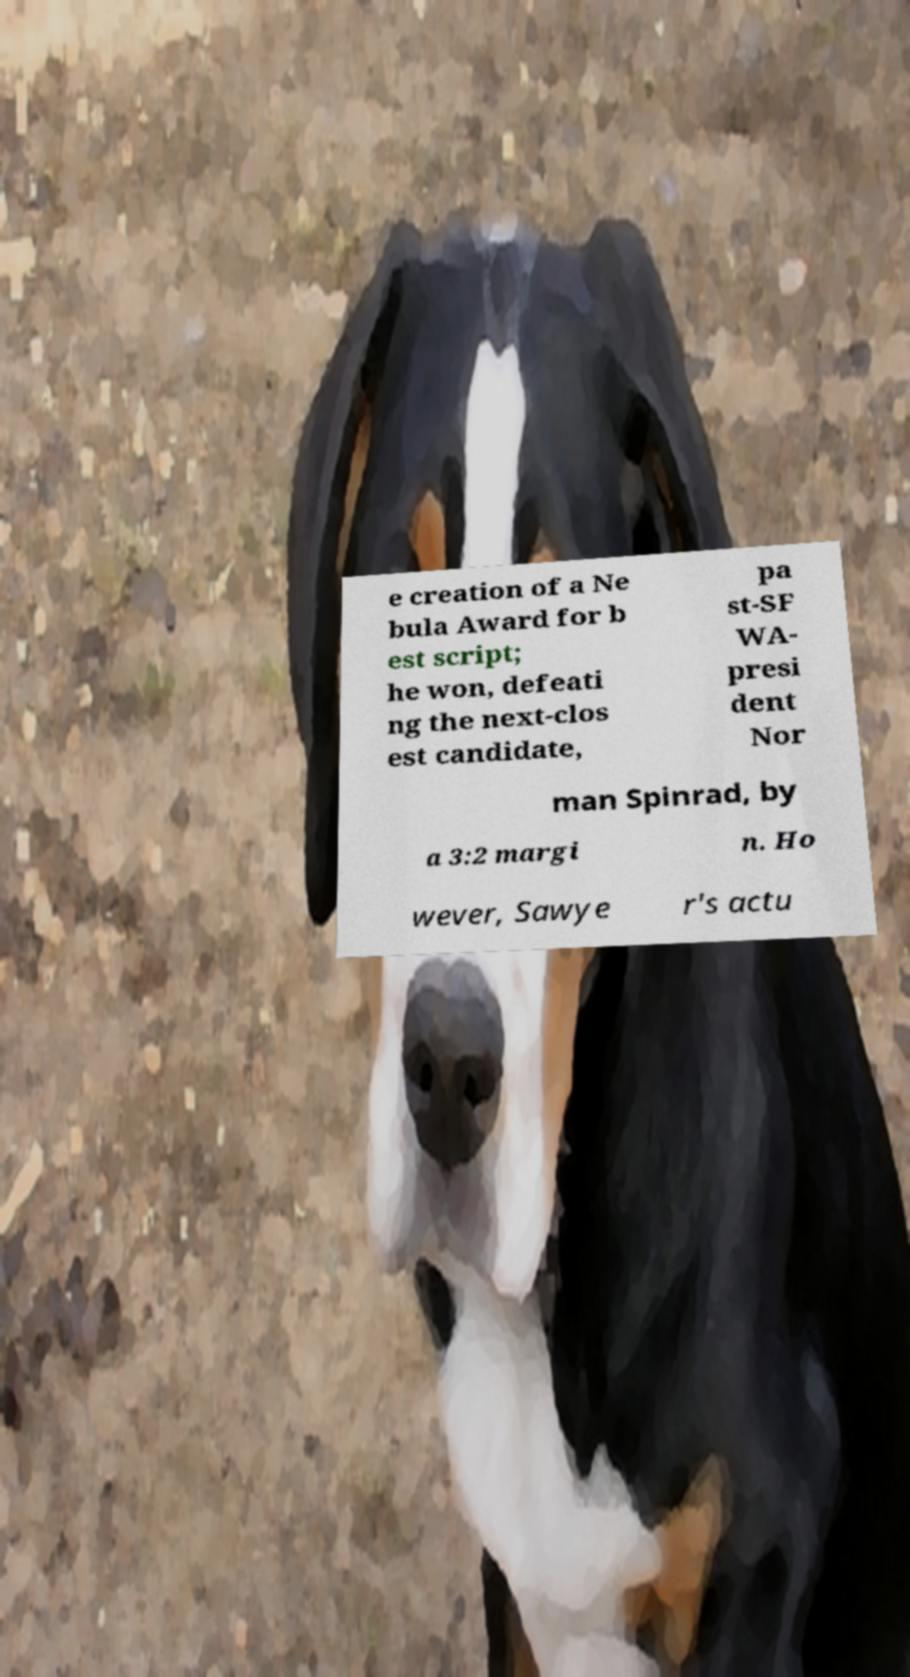Could you extract and type out the text from this image? e creation of a Ne bula Award for b est script; he won, defeati ng the next-clos est candidate, pa st-SF WA- presi dent Nor man Spinrad, by a 3:2 margi n. Ho wever, Sawye r's actu 